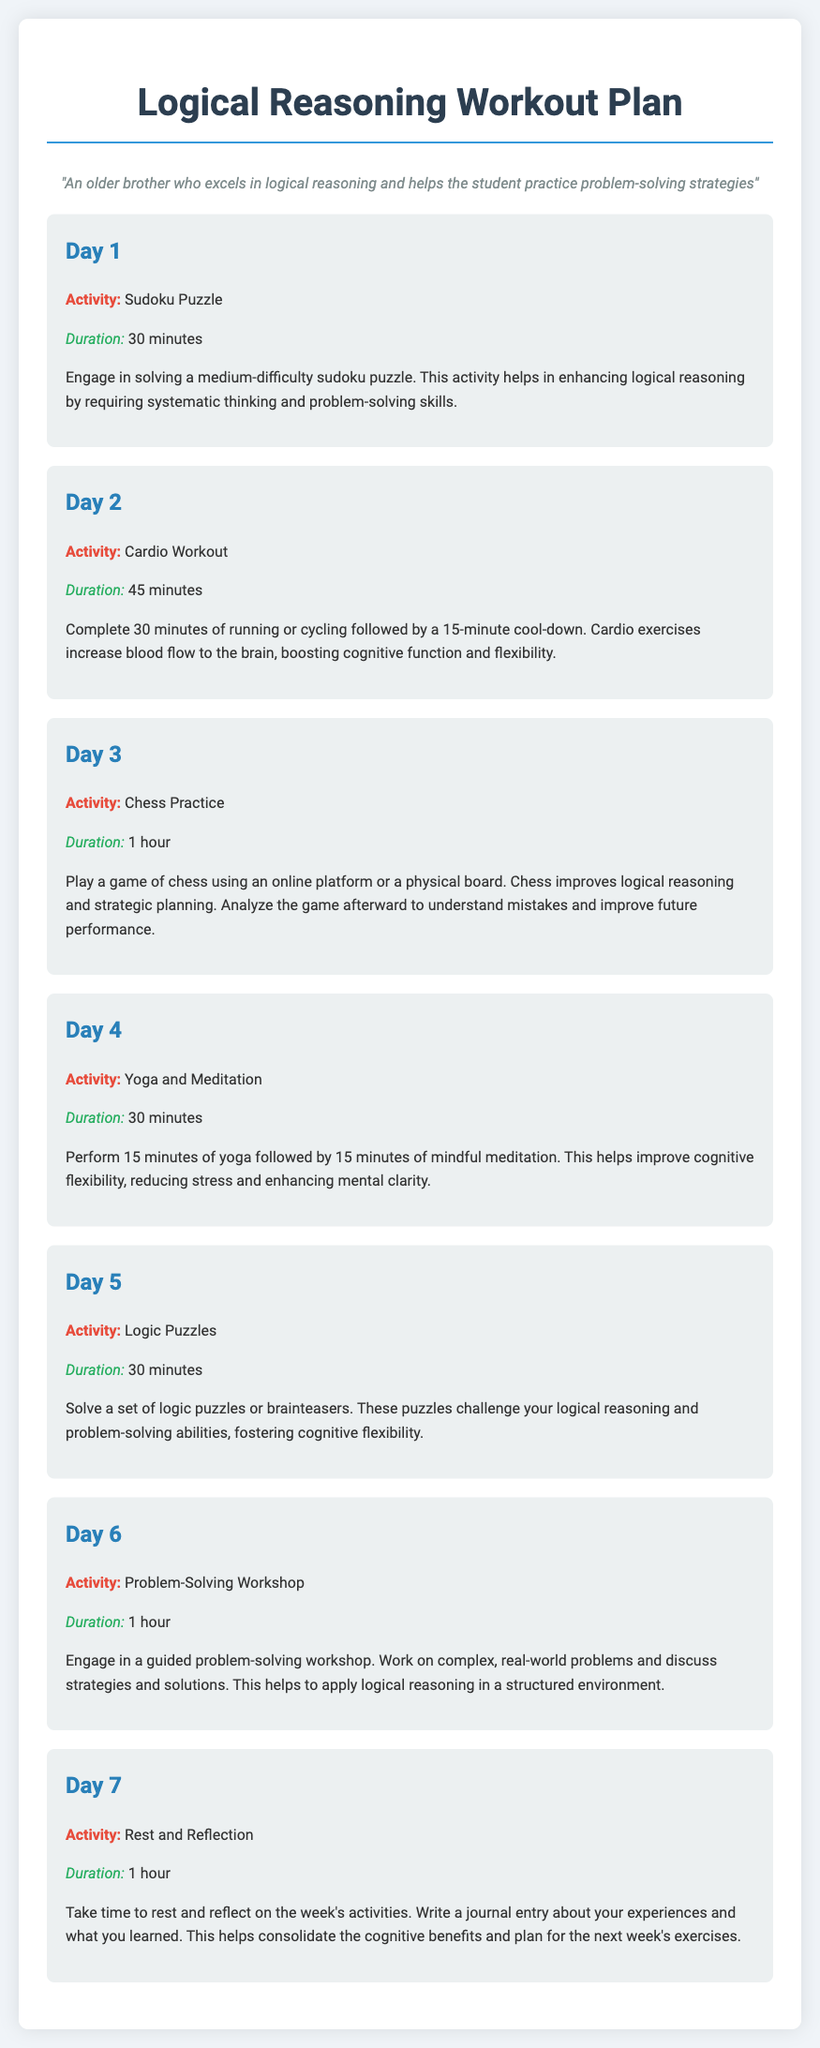What is the activity for Day 1? The activity for Day 1 is a Sudoku Puzzle, as listed in the document.
Answer: Sudoku Puzzle What is the duration of the Cardio Workout? The duration of the Cardio Workout on Day 2 is specified as 45 minutes.
Answer: 45 minutes Which activity enhances cognitive flexibility? The Yoga and Meditation activity on Day 4 is designed to improve cognitive flexibility according to the description.
Answer: Yoga and Meditation How long is the Problem-Solving Workshop? The Problem-Solving Workshop scheduled for Day 6 lasts for 1 hour.
Answer: 1 hour What activity is scheduled for Day 5? The activity planned for Day 5 is solving Logic Puzzles, as mentioned in the document.
Answer: Logic Puzzles Why is cardio important according to the plan? Cardio exercises are highlighted because they increase blood flow to the brain, which boosts cognitive function and flexibility.
Answer: Boost cognitive function and flexibility What should you do on Day 7? On Day 7, the plan recommends Rest and Reflection activities to consolidate cognitive benefits.
Answer: Rest and Reflection 